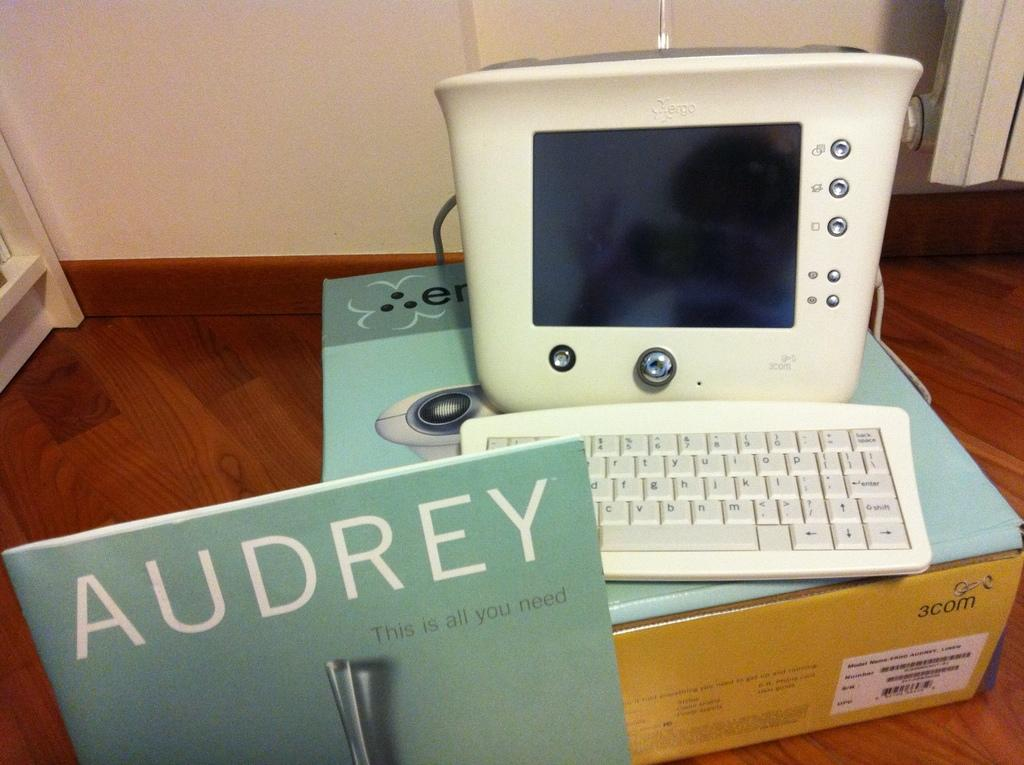<image>
Offer a succinct explanation of the picture presented. The book with the teal cover is called Audrey 